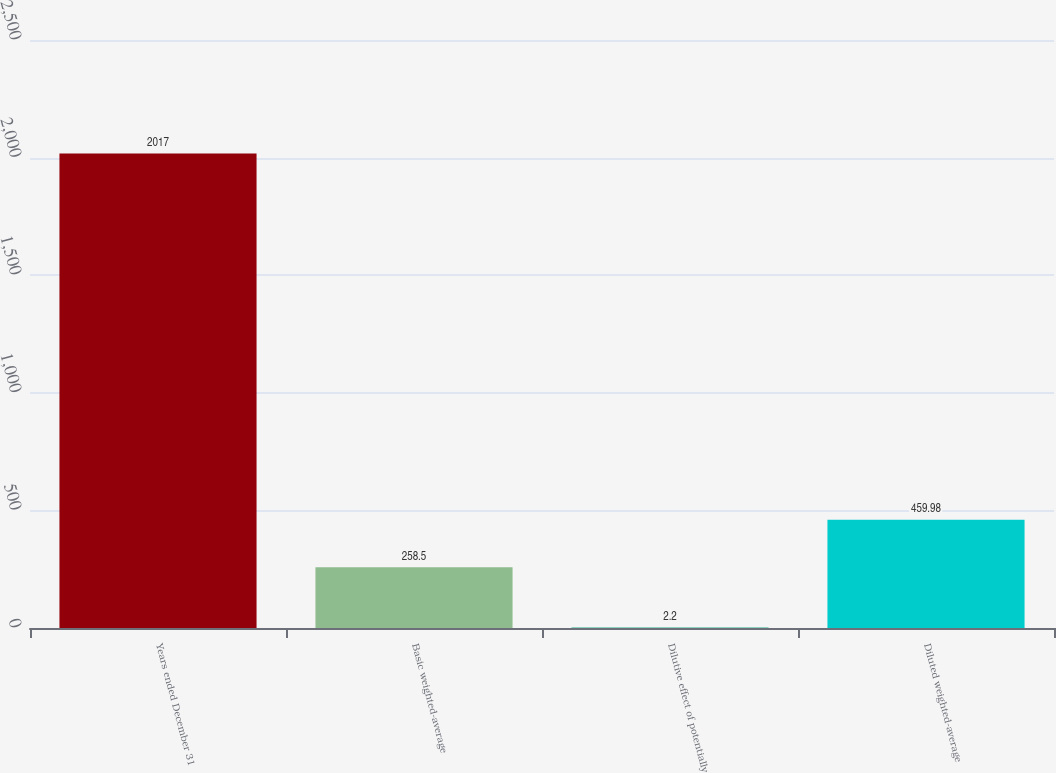Convert chart to OTSL. <chart><loc_0><loc_0><loc_500><loc_500><bar_chart><fcel>Years ended December 31<fcel>Basic weighted-average<fcel>Dilutive effect of potentially<fcel>Diluted weighted-average<nl><fcel>2017<fcel>258.5<fcel>2.2<fcel>459.98<nl></chart> 